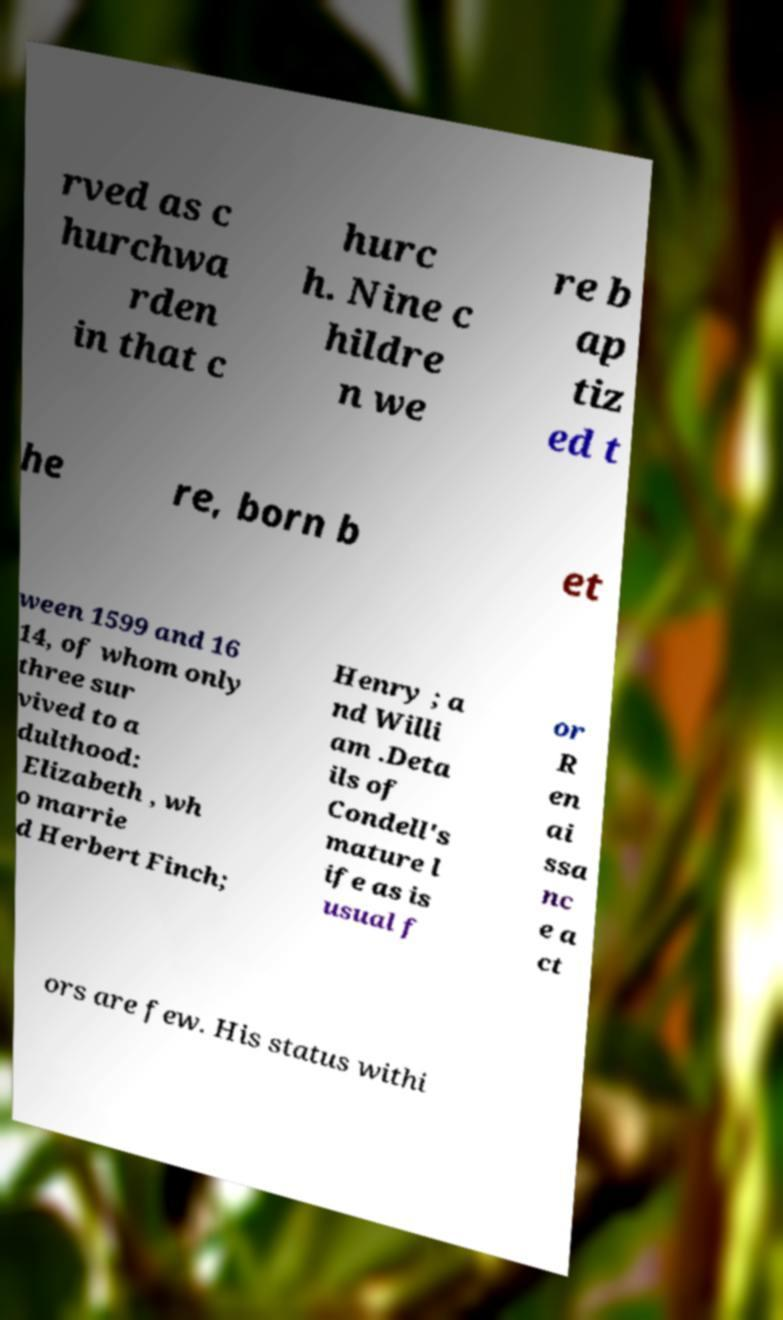I need the written content from this picture converted into text. Can you do that? rved as c hurchwa rden in that c hurc h. Nine c hildre n we re b ap tiz ed t he re, born b et ween 1599 and 16 14, of whom only three sur vived to a dulthood: Elizabeth , wh o marrie d Herbert Finch; Henry ; a nd Willi am .Deta ils of Condell's mature l ife as is usual f or R en ai ssa nc e a ct ors are few. His status withi 